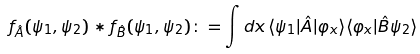Convert formula to latex. <formula><loc_0><loc_0><loc_500><loc_500>f _ { \hat { A } } ( \psi _ { 1 } , \psi _ { 2 } ) * f _ { \hat { B } } ( \psi _ { 1 } , \psi _ { 2 } ) \colon = \int d x \, \langle \psi _ { 1 } | \hat { A } | \varphi _ { x } \rangle \langle \varphi _ { x } | \hat { B } \psi _ { 2 } \rangle</formula> 